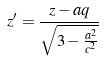Convert formula to latex. <formula><loc_0><loc_0><loc_500><loc_500>z ^ { \prime } = \frac { z - a q } { \sqrt { 3 - \frac { a ^ { 2 } } { c ^ { 2 } } } }</formula> 